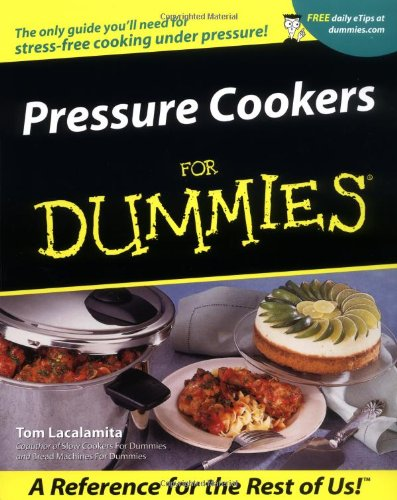Who wrote this book? The book 'Pressure Cookers For Dummies' was authored by Tom Lacalamita, who is also known for his work on other culinary guides. 